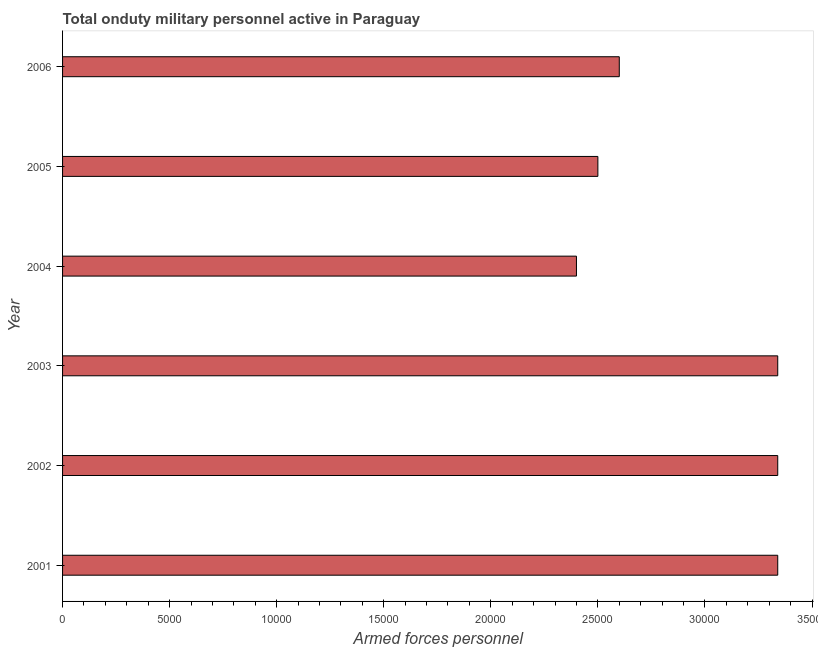What is the title of the graph?
Your response must be concise. Total onduty military personnel active in Paraguay. What is the label or title of the X-axis?
Offer a terse response. Armed forces personnel. What is the number of armed forces personnel in 2001?
Ensure brevity in your answer.  3.34e+04. Across all years, what is the maximum number of armed forces personnel?
Provide a succinct answer. 3.34e+04. Across all years, what is the minimum number of armed forces personnel?
Keep it short and to the point. 2.40e+04. In which year was the number of armed forces personnel maximum?
Provide a succinct answer. 2001. In which year was the number of armed forces personnel minimum?
Offer a terse response. 2004. What is the sum of the number of armed forces personnel?
Your response must be concise. 1.75e+05. What is the difference between the number of armed forces personnel in 2003 and 2004?
Your response must be concise. 9400. What is the average number of armed forces personnel per year?
Provide a succinct answer. 2.92e+04. What is the median number of armed forces personnel?
Keep it short and to the point. 2.97e+04. In how many years, is the number of armed forces personnel greater than 34000 ?
Your answer should be very brief. 0. What is the ratio of the number of armed forces personnel in 2002 to that in 2005?
Offer a very short reply. 1.34. Is the difference between the number of armed forces personnel in 2001 and 2002 greater than the difference between any two years?
Offer a very short reply. No. What is the difference between the highest and the second highest number of armed forces personnel?
Give a very brief answer. 0. Is the sum of the number of armed forces personnel in 2002 and 2003 greater than the maximum number of armed forces personnel across all years?
Offer a very short reply. Yes. What is the difference between the highest and the lowest number of armed forces personnel?
Offer a very short reply. 9400. How many years are there in the graph?
Give a very brief answer. 6. What is the Armed forces personnel of 2001?
Give a very brief answer. 3.34e+04. What is the Armed forces personnel in 2002?
Your answer should be compact. 3.34e+04. What is the Armed forces personnel in 2003?
Your answer should be very brief. 3.34e+04. What is the Armed forces personnel in 2004?
Make the answer very short. 2.40e+04. What is the Armed forces personnel of 2005?
Ensure brevity in your answer.  2.50e+04. What is the Armed forces personnel of 2006?
Ensure brevity in your answer.  2.60e+04. What is the difference between the Armed forces personnel in 2001 and 2002?
Provide a succinct answer. 0. What is the difference between the Armed forces personnel in 2001 and 2003?
Ensure brevity in your answer.  0. What is the difference between the Armed forces personnel in 2001 and 2004?
Your response must be concise. 9400. What is the difference between the Armed forces personnel in 2001 and 2005?
Keep it short and to the point. 8400. What is the difference between the Armed forces personnel in 2001 and 2006?
Ensure brevity in your answer.  7400. What is the difference between the Armed forces personnel in 2002 and 2004?
Keep it short and to the point. 9400. What is the difference between the Armed forces personnel in 2002 and 2005?
Provide a succinct answer. 8400. What is the difference between the Armed forces personnel in 2002 and 2006?
Give a very brief answer. 7400. What is the difference between the Armed forces personnel in 2003 and 2004?
Offer a terse response. 9400. What is the difference between the Armed forces personnel in 2003 and 2005?
Provide a succinct answer. 8400. What is the difference between the Armed forces personnel in 2003 and 2006?
Ensure brevity in your answer.  7400. What is the difference between the Armed forces personnel in 2004 and 2005?
Ensure brevity in your answer.  -1000. What is the difference between the Armed forces personnel in 2004 and 2006?
Your response must be concise. -2000. What is the difference between the Armed forces personnel in 2005 and 2006?
Your response must be concise. -1000. What is the ratio of the Armed forces personnel in 2001 to that in 2003?
Provide a short and direct response. 1. What is the ratio of the Armed forces personnel in 2001 to that in 2004?
Provide a short and direct response. 1.39. What is the ratio of the Armed forces personnel in 2001 to that in 2005?
Provide a short and direct response. 1.34. What is the ratio of the Armed forces personnel in 2001 to that in 2006?
Make the answer very short. 1.28. What is the ratio of the Armed forces personnel in 2002 to that in 2003?
Your answer should be compact. 1. What is the ratio of the Armed forces personnel in 2002 to that in 2004?
Offer a very short reply. 1.39. What is the ratio of the Armed forces personnel in 2002 to that in 2005?
Provide a succinct answer. 1.34. What is the ratio of the Armed forces personnel in 2002 to that in 2006?
Provide a succinct answer. 1.28. What is the ratio of the Armed forces personnel in 2003 to that in 2004?
Your response must be concise. 1.39. What is the ratio of the Armed forces personnel in 2003 to that in 2005?
Provide a short and direct response. 1.34. What is the ratio of the Armed forces personnel in 2003 to that in 2006?
Your answer should be compact. 1.28. What is the ratio of the Armed forces personnel in 2004 to that in 2005?
Keep it short and to the point. 0.96. What is the ratio of the Armed forces personnel in 2004 to that in 2006?
Give a very brief answer. 0.92. What is the ratio of the Armed forces personnel in 2005 to that in 2006?
Your response must be concise. 0.96. 